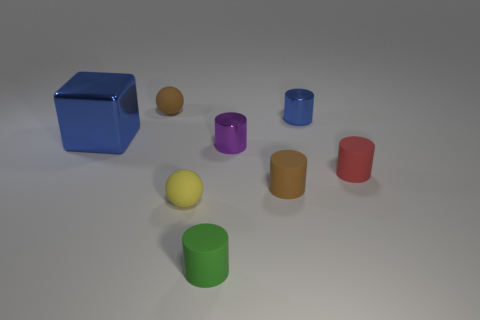How many tiny objects are metallic cubes or things?
Your answer should be very brief. 7. There is a ball left of the yellow rubber sphere; are there any green things that are to the left of it?
Your answer should be very brief. No. Are there any tiny brown rubber spheres?
Your answer should be compact. Yes. There is a small matte sphere in front of the sphere that is behind the tiny red cylinder; what is its color?
Your answer should be compact. Yellow. What material is the tiny blue object that is the same shape as the tiny red object?
Your answer should be very brief. Metal. How many yellow matte cylinders are the same size as the red matte object?
Ensure brevity in your answer.  0. What is the size of the purple cylinder that is made of the same material as the big blue thing?
Ensure brevity in your answer.  Small. How many other small rubber objects have the same shape as the yellow object?
Keep it short and to the point. 1. What number of blocks are there?
Provide a succinct answer. 1. There is a tiny brown rubber thing to the right of the green cylinder; does it have the same shape as the purple metal thing?
Provide a short and direct response. Yes. 